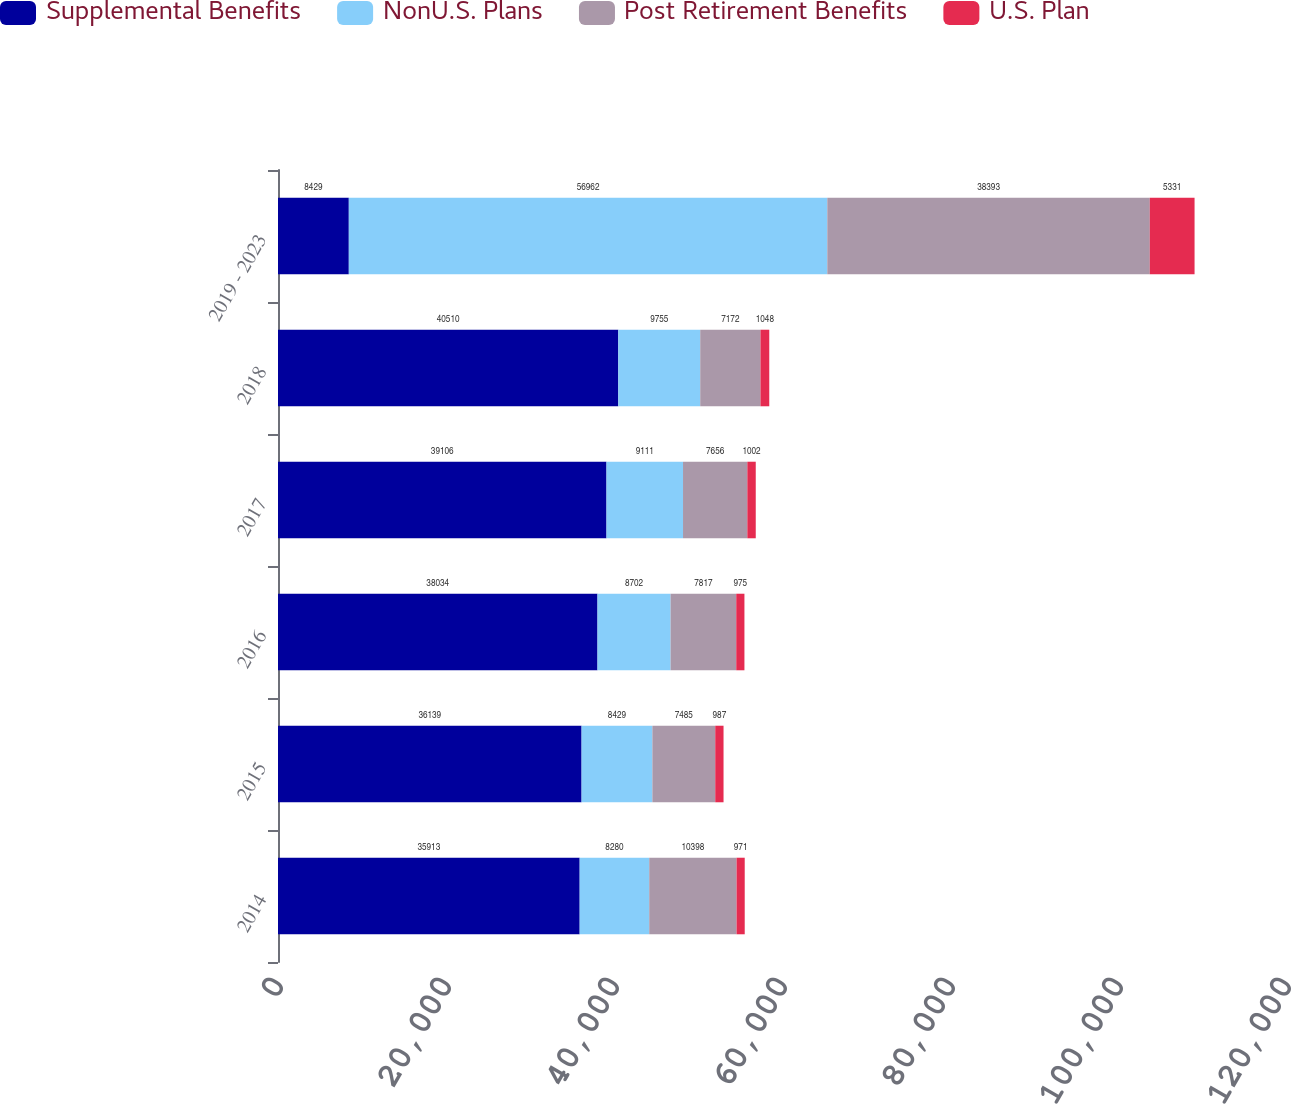<chart> <loc_0><loc_0><loc_500><loc_500><stacked_bar_chart><ecel><fcel>2014<fcel>2015<fcel>2016<fcel>2017<fcel>2018<fcel>2019 - 2023<nl><fcel>Supplemental Benefits<fcel>35913<fcel>36139<fcel>38034<fcel>39106<fcel>40510<fcel>8429<nl><fcel>NonU.S. Plans<fcel>8280<fcel>8429<fcel>8702<fcel>9111<fcel>9755<fcel>56962<nl><fcel>Post Retirement Benefits<fcel>10398<fcel>7485<fcel>7817<fcel>7656<fcel>7172<fcel>38393<nl><fcel>U.S. Plan<fcel>971<fcel>987<fcel>975<fcel>1002<fcel>1048<fcel>5331<nl></chart> 